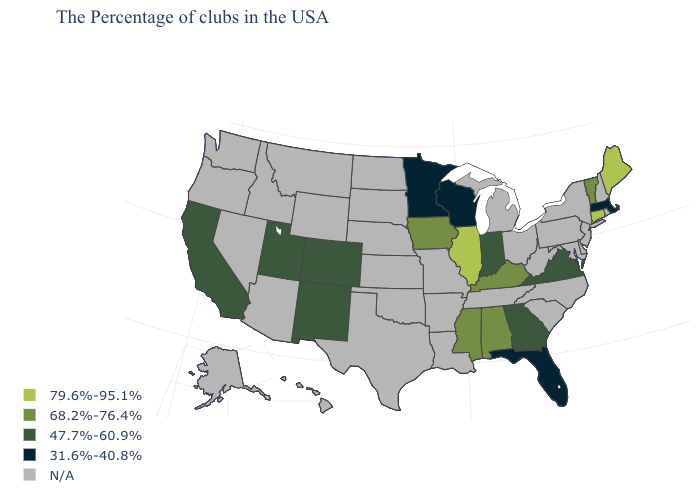Name the states that have a value in the range N/A?
Write a very short answer. Rhode Island, New Hampshire, New York, New Jersey, Delaware, Maryland, Pennsylvania, North Carolina, South Carolina, West Virginia, Ohio, Michigan, Tennessee, Louisiana, Missouri, Arkansas, Kansas, Nebraska, Oklahoma, Texas, South Dakota, North Dakota, Wyoming, Montana, Arizona, Idaho, Nevada, Washington, Oregon, Alaska, Hawaii. What is the value of Iowa?
Keep it brief. 68.2%-76.4%. How many symbols are there in the legend?
Answer briefly. 5. What is the value of South Dakota?
Write a very short answer. N/A. Name the states that have a value in the range 31.6%-40.8%?
Give a very brief answer. Massachusetts, Florida, Wisconsin, Minnesota. Name the states that have a value in the range 79.6%-95.1%?
Concise answer only. Maine, Connecticut, Illinois. Name the states that have a value in the range 68.2%-76.4%?
Short answer required. Vermont, Kentucky, Alabama, Mississippi, Iowa. Name the states that have a value in the range 79.6%-95.1%?
Short answer required. Maine, Connecticut, Illinois. What is the highest value in the USA?
Be succinct. 79.6%-95.1%. Which states have the lowest value in the USA?
Quick response, please. Massachusetts, Florida, Wisconsin, Minnesota. What is the value of Wisconsin?
Concise answer only. 31.6%-40.8%. Name the states that have a value in the range 79.6%-95.1%?
Keep it brief. Maine, Connecticut, Illinois. What is the highest value in states that border South Dakota?
Quick response, please. 68.2%-76.4%. 